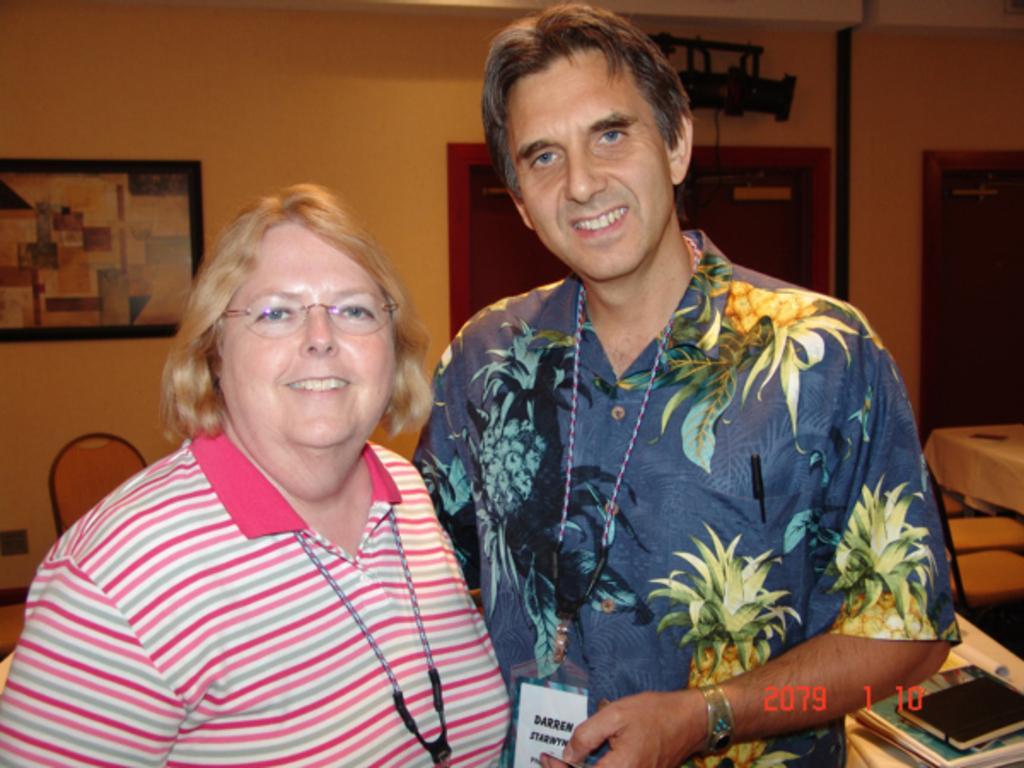Please provide a concise description of this image. In this picture we observe two people posing for a picture and in the background we observe a board attached to the background and there is a watermark of a number which is 2079110 down the image. 